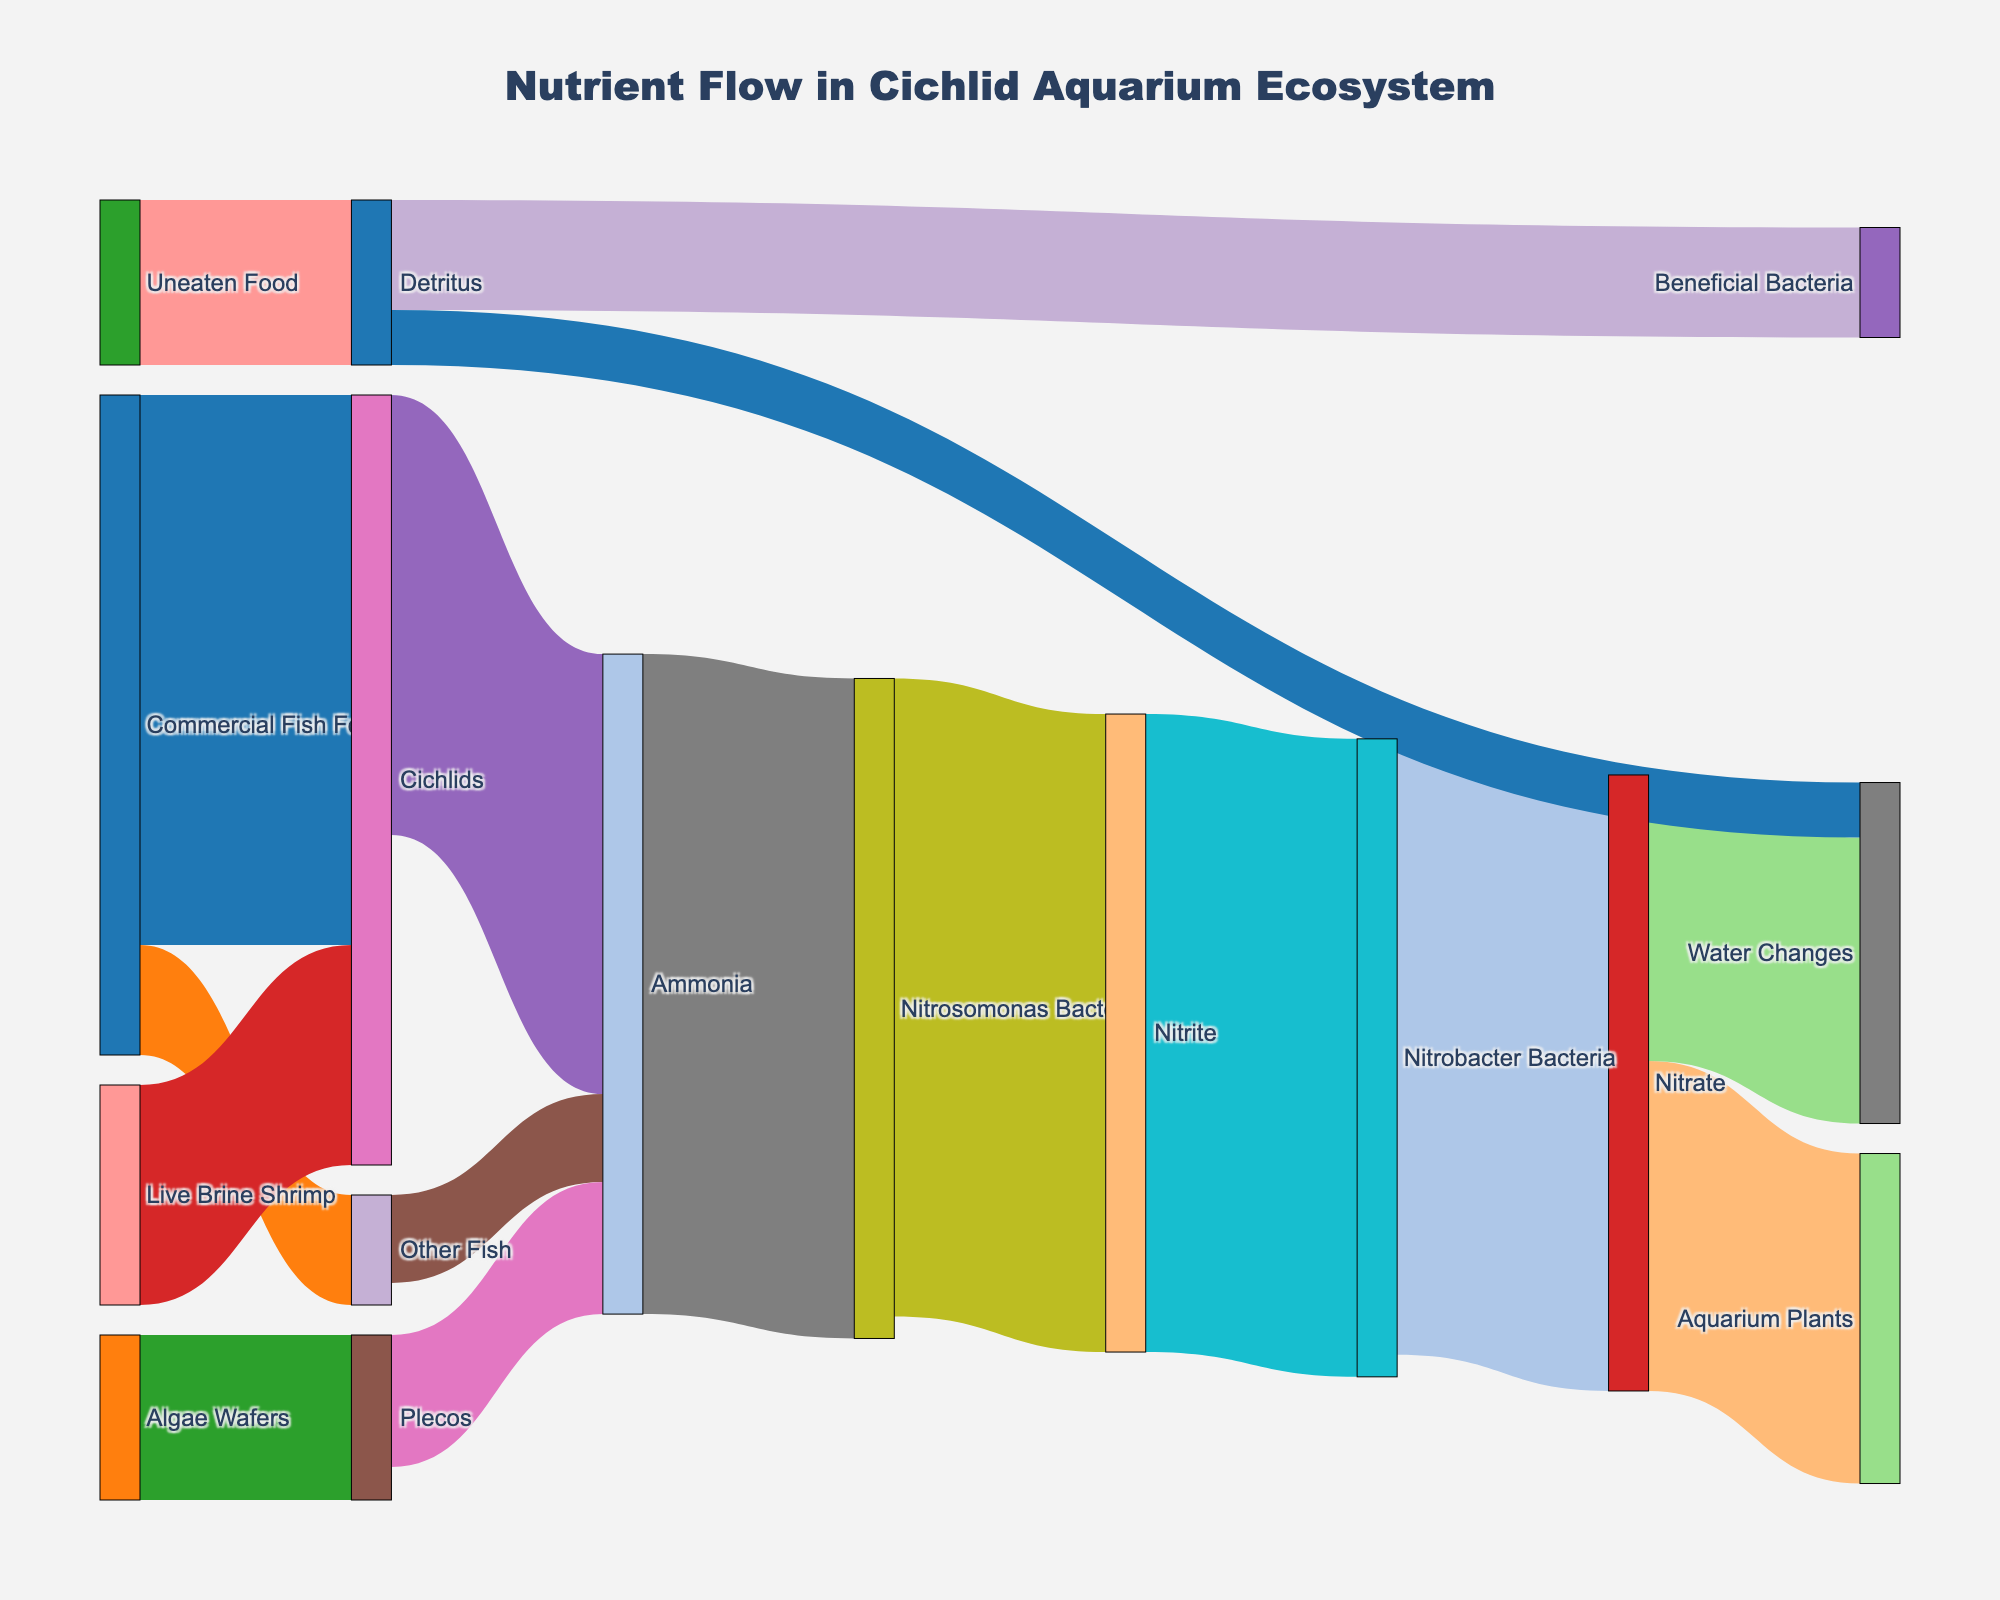What is the most common source of nutrients for cichlids in the aquarium? The Sankey diagram shows flows of nutrient sources to cichlids. By identifying the sources connected to cichlids, you can see that Commercial Fish Food has the highest value (50) among them.
Answer: Commercial Fish Food How does Ammonia leave the cichlid aquarium ecosystem? By tracing the flow from Ammonia in the diagram, you find that Ammonia flows to Nitrosomonas Bacteria with a value of 60. Then, Nitrosomonas Bacteria converts it to Nitrite, which further gets converted by Nitrobacter Bacteria into Nitrate, which finally flows to Aquarium Plants and Water Changes.
Answer: Through Nitrosomonas Bacteria, Nitrite, Nitrobacter Bacteria, Nitrate, Aquarium Plants, and Water Changes Which organism or component produces the most waste in the form of Ammonia? The Sankey diagram shows flows leading to Ammonia. By comparing the values, you see Cichlids produce 40 units, Other Fish produce 8 units, and Plecos produce 12 units. The highest value is 40 from Cichlids.
Answer: Cichlids What is the total amount of Nitrate that gets processed by the system, and how is it distributed? By summing the values from the flows of Nitrate, you see that 30 units are taken up by Aquarium Plants and 26 units are removed through Water Changes. The total is 30 + 26 = 56 units.
Answer: 56 units (30 to Aquarium Plants, 26 to Water Changes) How does unconsumed food affect the nutrient flow in the aquarium? The diagram shows that Uneaten Food flows into Detritus with a value of 15. Detritus then splits into Beneficial Bacteria (10) and Water Changes (5). This reveals how uneaten food disrupts the nutrient balance by creating Detritus, which requires further processing.
Answer: It turns into Detritus, processed by Beneficial Bacteria (10) and Water Changes (5) Are there any nutrients or components that don't change state more than once? By tracing each path in the diagram, you find that Commercial Fish Food, Live Brine Shrimp, and Uneaten Food only flow once before converting or getting processed further.
Answer: Yes, Commercial Fish Food, Live Brine Shrimp, Uneaten Food Which beneficial bacteria is responsible for converting Ammonia, and what does it produce? The diagram shows Ammonia flows into Nitrosomonas Bacteria. From there, Nitrosomonas Bacteria produces Nitrite.
Answer: Nitrosomonas Bacteria, Nitrite 